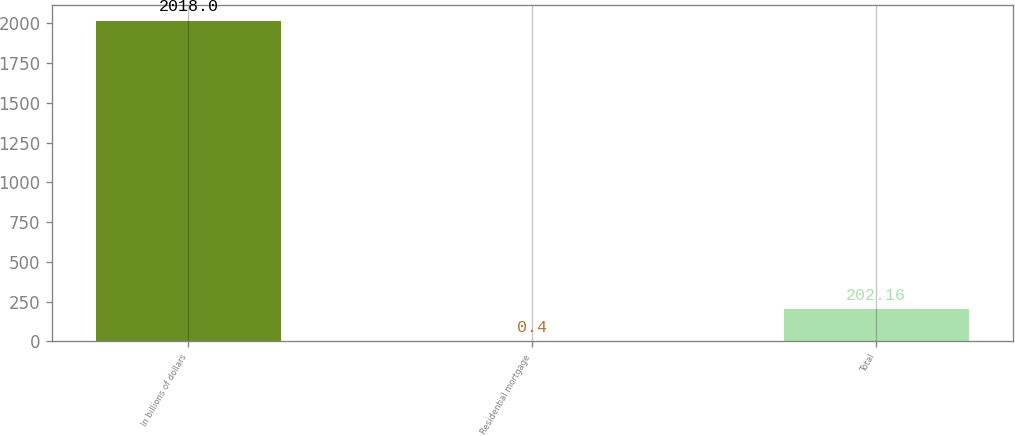Convert chart. <chart><loc_0><loc_0><loc_500><loc_500><bar_chart><fcel>In billions of dollars<fcel>Residential mortgage<fcel>Total<nl><fcel>2018<fcel>0.4<fcel>202.16<nl></chart> 